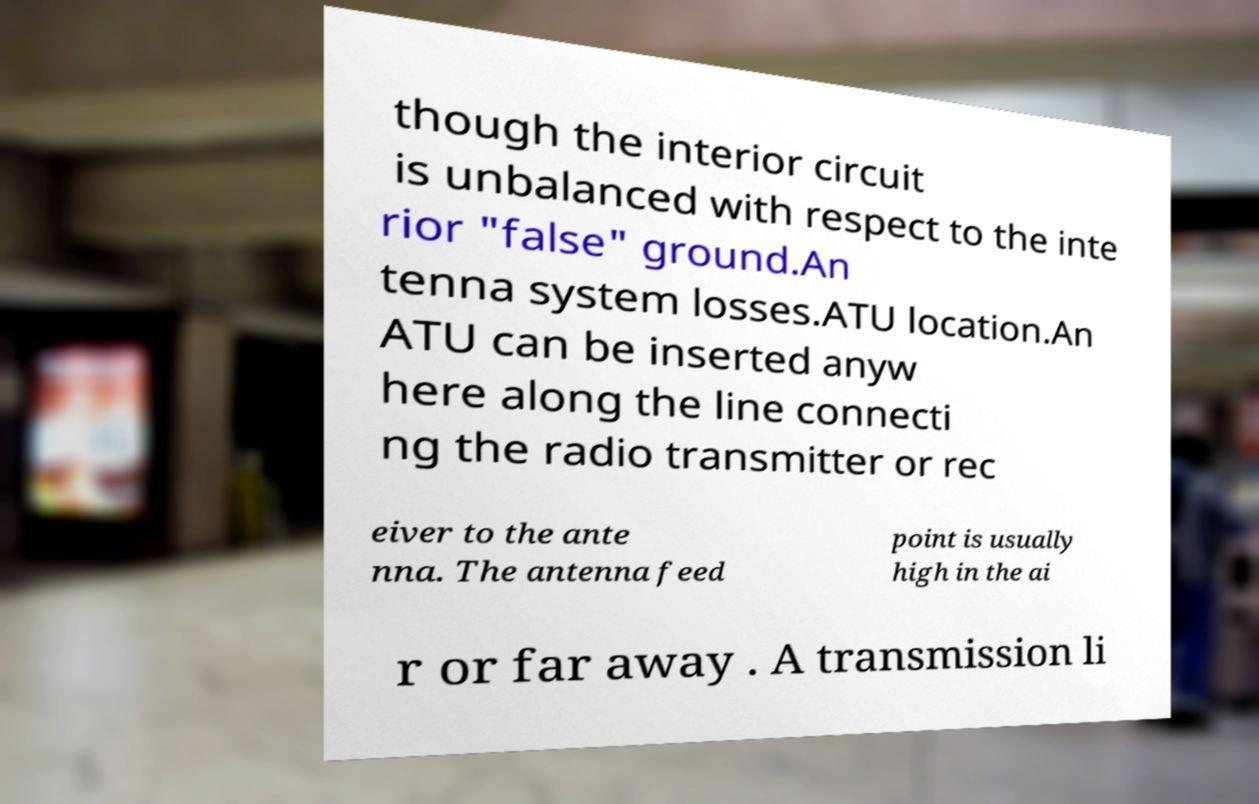Can you accurately transcribe the text from the provided image for me? though the interior circuit is unbalanced with respect to the inte rior "false" ground.An tenna system losses.ATU location.An ATU can be inserted anyw here along the line connecti ng the radio transmitter or rec eiver to the ante nna. The antenna feed point is usually high in the ai r or far away . A transmission li 